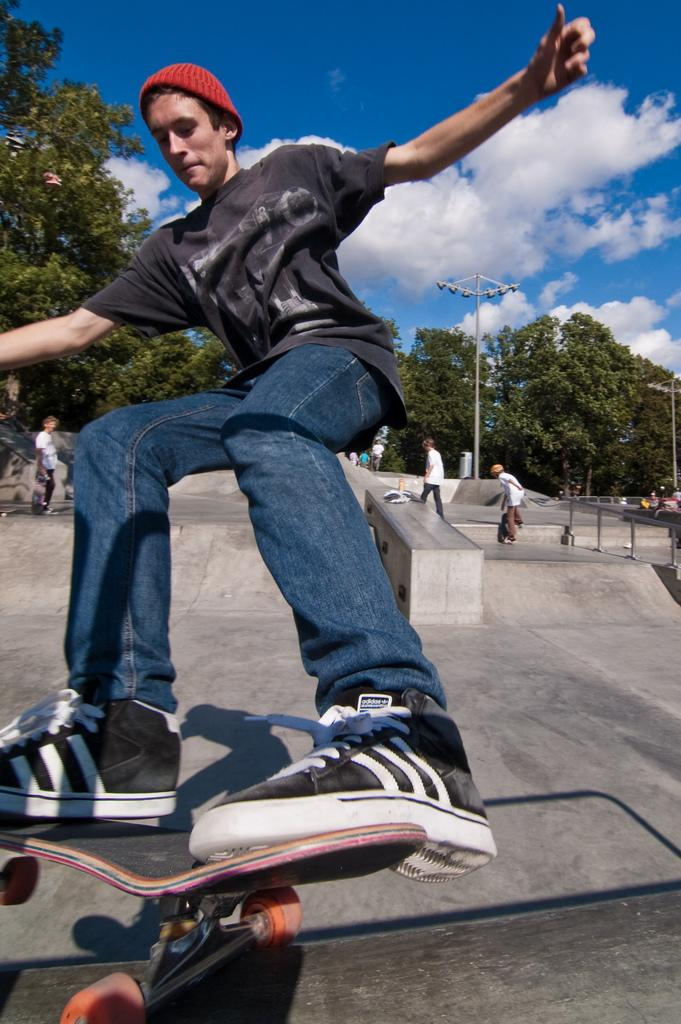Where was the image taken? The image was clicked outside. What can be seen in the middle of the image? There are trees and people skating in the middle of the image. What is visible at the top of the image? The sky is visible at the top of the image. What type of vegetable is being used as a prop by the skaters in the image? There are no vegetables present in the image, and the skaters are not using any props. Whose birthday is being celebrated in the image? There is no indication of a birthday celebration in the image. 